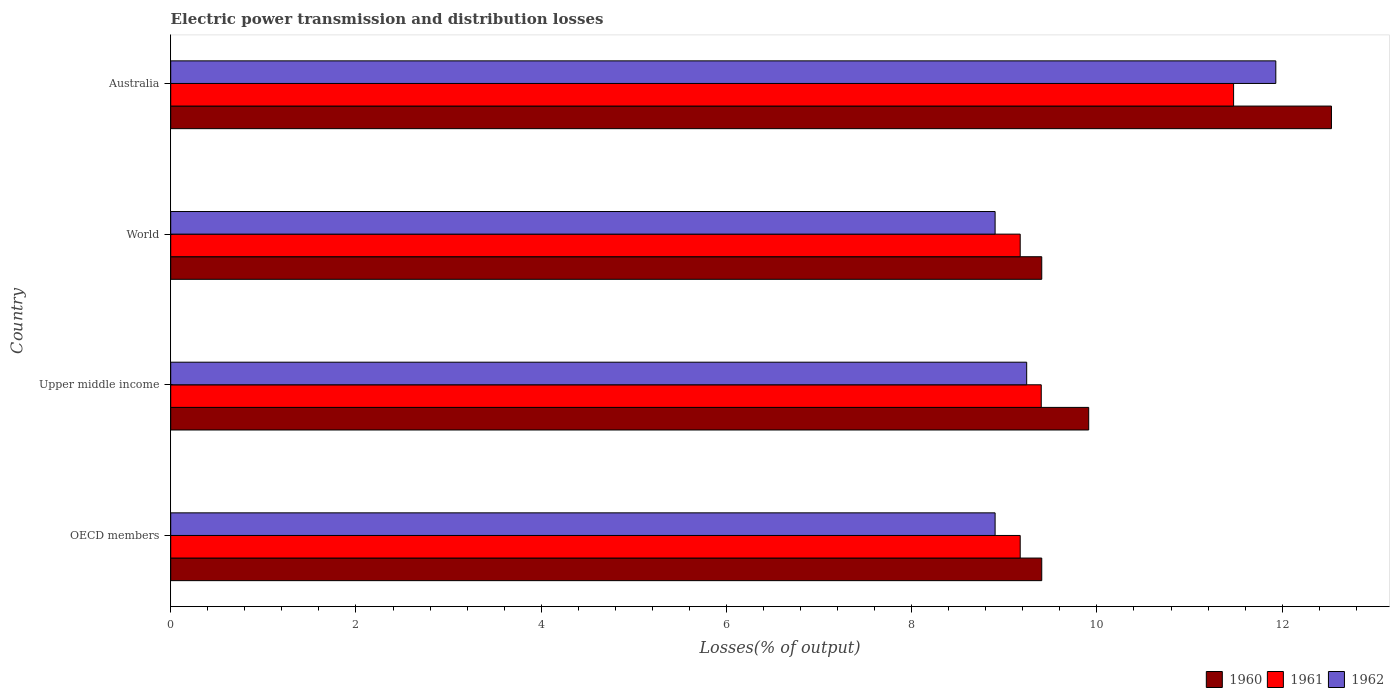How many different coloured bars are there?
Provide a succinct answer. 3. Are the number of bars per tick equal to the number of legend labels?
Offer a very short reply. Yes. Are the number of bars on each tick of the Y-axis equal?
Ensure brevity in your answer.  Yes. How many bars are there on the 4th tick from the top?
Your answer should be compact. 3. What is the label of the 3rd group of bars from the top?
Your answer should be compact. Upper middle income. In how many cases, is the number of bars for a given country not equal to the number of legend labels?
Keep it short and to the point. 0. What is the electric power transmission and distribution losses in 1960 in OECD members?
Make the answer very short. 9.4. Across all countries, what is the maximum electric power transmission and distribution losses in 1962?
Make the answer very short. 11.93. Across all countries, what is the minimum electric power transmission and distribution losses in 1961?
Your answer should be compact. 9.17. In which country was the electric power transmission and distribution losses in 1960 maximum?
Provide a succinct answer. Australia. What is the total electric power transmission and distribution losses in 1962 in the graph?
Make the answer very short. 38.97. What is the difference between the electric power transmission and distribution losses in 1962 in OECD members and that in Upper middle income?
Offer a very short reply. -0.34. What is the difference between the electric power transmission and distribution losses in 1960 in Upper middle income and the electric power transmission and distribution losses in 1962 in OECD members?
Make the answer very short. 1.01. What is the average electric power transmission and distribution losses in 1962 per country?
Make the answer very short. 9.74. What is the difference between the electric power transmission and distribution losses in 1961 and electric power transmission and distribution losses in 1960 in Australia?
Your response must be concise. -1.06. In how many countries, is the electric power transmission and distribution losses in 1961 greater than 9.6 %?
Make the answer very short. 1. What is the ratio of the electric power transmission and distribution losses in 1961 in Australia to that in Upper middle income?
Provide a short and direct response. 1.22. Is the electric power transmission and distribution losses in 1961 in Australia less than that in World?
Give a very brief answer. No. Is the difference between the electric power transmission and distribution losses in 1961 in Upper middle income and World greater than the difference between the electric power transmission and distribution losses in 1960 in Upper middle income and World?
Your answer should be very brief. No. What is the difference between the highest and the second highest electric power transmission and distribution losses in 1961?
Offer a terse response. 2.08. What is the difference between the highest and the lowest electric power transmission and distribution losses in 1962?
Your answer should be compact. 3.03. In how many countries, is the electric power transmission and distribution losses in 1962 greater than the average electric power transmission and distribution losses in 1962 taken over all countries?
Offer a terse response. 1. What does the 3rd bar from the top in World represents?
Provide a succinct answer. 1960. Are all the bars in the graph horizontal?
Provide a short and direct response. Yes. How many countries are there in the graph?
Your response must be concise. 4. What is the difference between two consecutive major ticks on the X-axis?
Your answer should be compact. 2. Are the values on the major ticks of X-axis written in scientific E-notation?
Make the answer very short. No. Does the graph contain grids?
Your answer should be compact. No. What is the title of the graph?
Provide a succinct answer. Electric power transmission and distribution losses. What is the label or title of the X-axis?
Your response must be concise. Losses(% of output). What is the label or title of the Y-axis?
Provide a short and direct response. Country. What is the Losses(% of output) of 1960 in OECD members?
Your response must be concise. 9.4. What is the Losses(% of output) of 1961 in OECD members?
Keep it short and to the point. 9.17. What is the Losses(% of output) in 1962 in OECD members?
Your response must be concise. 8.9. What is the Losses(% of output) in 1960 in Upper middle income?
Your answer should be compact. 9.91. What is the Losses(% of output) of 1961 in Upper middle income?
Your answer should be very brief. 9.4. What is the Losses(% of output) of 1962 in Upper middle income?
Your answer should be compact. 9.24. What is the Losses(% of output) in 1960 in World?
Your answer should be very brief. 9.4. What is the Losses(% of output) of 1961 in World?
Offer a very short reply. 9.17. What is the Losses(% of output) of 1962 in World?
Give a very brief answer. 8.9. What is the Losses(% of output) in 1960 in Australia?
Keep it short and to the point. 12.53. What is the Losses(% of output) of 1961 in Australia?
Your answer should be compact. 11.48. What is the Losses(% of output) of 1962 in Australia?
Your answer should be very brief. 11.93. Across all countries, what is the maximum Losses(% of output) in 1960?
Offer a very short reply. 12.53. Across all countries, what is the maximum Losses(% of output) of 1961?
Ensure brevity in your answer.  11.48. Across all countries, what is the maximum Losses(% of output) of 1962?
Provide a succinct answer. 11.93. Across all countries, what is the minimum Losses(% of output) in 1960?
Your response must be concise. 9.4. Across all countries, what is the minimum Losses(% of output) in 1961?
Keep it short and to the point. 9.17. Across all countries, what is the minimum Losses(% of output) in 1962?
Your answer should be compact. 8.9. What is the total Losses(% of output) in 1960 in the graph?
Your answer should be very brief. 41.25. What is the total Losses(% of output) of 1961 in the graph?
Provide a short and direct response. 39.22. What is the total Losses(% of output) in 1962 in the graph?
Offer a terse response. 38.97. What is the difference between the Losses(% of output) of 1960 in OECD members and that in Upper middle income?
Your answer should be compact. -0.51. What is the difference between the Losses(% of output) in 1961 in OECD members and that in Upper middle income?
Offer a terse response. -0.23. What is the difference between the Losses(% of output) in 1962 in OECD members and that in Upper middle income?
Give a very brief answer. -0.34. What is the difference between the Losses(% of output) of 1962 in OECD members and that in World?
Your response must be concise. 0. What is the difference between the Losses(% of output) in 1960 in OECD members and that in Australia?
Offer a very short reply. -3.13. What is the difference between the Losses(% of output) in 1961 in OECD members and that in Australia?
Your response must be concise. -2.3. What is the difference between the Losses(% of output) of 1962 in OECD members and that in Australia?
Provide a short and direct response. -3.03. What is the difference between the Losses(% of output) in 1960 in Upper middle income and that in World?
Provide a succinct answer. 0.51. What is the difference between the Losses(% of output) in 1961 in Upper middle income and that in World?
Make the answer very short. 0.23. What is the difference between the Losses(% of output) of 1962 in Upper middle income and that in World?
Provide a short and direct response. 0.34. What is the difference between the Losses(% of output) of 1960 in Upper middle income and that in Australia?
Ensure brevity in your answer.  -2.62. What is the difference between the Losses(% of output) of 1961 in Upper middle income and that in Australia?
Keep it short and to the point. -2.08. What is the difference between the Losses(% of output) in 1962 in Upper middle income and that in Australia?
Make the answer very short. -2.69. What is the difference between the Losses(% of output) in 1960 in World and that in Australia?
Give a very brief answer. -3.13. What is the difference between the Losses(% of output) of 1961 in World and that in Australia?
Offer a very short reply. -2.3. What is the difference between the Losses(% of output) of 1962 in World and that in Australia?
Give a very brief answer. -3.03. What is the difference between the Losses(% of output) of 1960 in OECD members and the Losses(% of output) of 1961 in Upper middle income?
Give a very brief answer. 0.01. What is the difference between the Losses(% of output) in 1960 in OECD members and the Losses(% of output) in 1962 in Upper middle income?
Provide a short and direct response. 0.16. What is the difference between the Losses(% of output) in 1961 in OECD members and the Losses(% of output) in 1962 in Upper middle income?
Provide a short and direct response. -0.07. What is the difference between the Losses(% of output) of 1960 in OECD members and the Losses(% of output) of 1961 in World?
Provide a succinct answer. 0.23. What is the difference between the Losses(% of output) in 1960 in OECD members and the Losses(% of output) in 1962 in World?
Keep it short and to the point. 0.5. What is the difference between the Losses(% of output) in 1961 in OECD members and the Losses(% of output) in 1962 in World?
Offer a very short reply. 0.27. What is the difference between the Losses(% of output) in 1960 in OECD members and the Losses(% of output) in 1961 in Australia?
Your answer should be compact. -2.07. What is the difference between the Losses(% of output) in 1960 in OECD members and the Losses(% of output) in 1962 in Australia?
Keep it short and to the point. -2.53. What is the difference between the Losses(% of output) in 1961 in OECD members and the Losses(% of output) in 1962 in Australia?
Provide a succinct answer. -2.76. What is the difference between the Losses(% of output) in 1960 in Upper middle income and the Losses(% of output) in 1961 in World?
Ensure brevity in your answer.  0.74. What is the difference between the Losses(% of output) of 1960 in Upper middle income and the Losses(% of output) of 1962 in World?
Offer a terse response. 1.01. What is the difference between the Losses(% of output) in 1961 in Upper middle income and the Losses(% of output) in 1962 in World?
Provide a succinct answer. 0.5. What is the difference between the Losses(% of output) in 1960 in Upper middle income and the Losses(% of output) in 1961 in Australia?
Offer a very short reply. -1.56. What is the difference between the Losses(% of output) of 1960 in Upper middle income and the Losses(% of output) of 1962 in Australia?
Keep it short and to the point. -2.02. What is the difference between the Losses(% of output) in 1961 in Upper middle income and the Losses(% of output) in 1962 in Australia?
Your response must be concise. -2.53. What is the difference between the Losses(% of output) of 1960 in World and the Losses(% of output) of 1961 in Australia?
Offer a very short reply. -2.07. What is the difference between the Losses(% of output) in 1960 in World and the Losses(% of output) in 1962 in Australia?
Ensure brevity in your answer.  -2.53. What is the difference between the Losses(% of output) in 1961 in World and the Losses(% of output) in 1962 in Australia?
Your answer should be compact. -2.76. What is the average Losses(% of output) in 1960 per country?
Provide a succinct answer. 10.31. What is the average Losses(% of output) in 1961 per country?
Keep it short and to the point. 9.8. What is the average Losses(% of output) in 1962 per country?
Provide a succinct answer. 9.74. What is the difference between the Losses(% of output) in 1960 and Losses(% of output) in 1961 in OECD members?
Offer a very short reply. 0.23. What is the difference between the Losses(% of output) in 1960 and Losses(% of output) in 1962 in OECD members?
Provide a succinct answer. 0.5. What is the difference between the Losses(% of output) in 1961 and Losses(% of output) in 1962 in OECD members?
Ensure brevity in your answer.  0.27. What is the difference between the Losses(% of output) of 1960 and Losses(% of output) of 1961 in Upper middle income?
Offer a very short reply. 0.51. What is the difference between the Losses(% of output) of 1960 and Losses(% of output) of 1962 in Upper middle income?
Provide a short and direct response. 0.67. What is the difference between the Losses(% of output) in 1961 and Losses(% of output) in 1962 in Upper middle income?
Provide a succinct answer. 0.16. What is the difference between the Losses(% of output) of 1960 and Losses(% of output) of 1961 in World?
Provide a succinct answer. 0.23. What is the difference between the Losses(% of output) in 1960 and Losses(% of output) in 1962 in World?
Provide a succinct answer. 0.5. What is the difference between the Losses(% of output) of 1961 and Losses(% of output) of 1962 in World?
Provide a short and direct response. 0.27. What is the difference between the Losses(% of output) of 1960 and Losses(% of output) of 1961 in Australia?
Keep it short and to the point. 1.06. What is the difference between the Losses(% of output) of 1960 and Losses(% of output) of 1962 in Australia?
Your response must be concise. 0.6. What is the difference between the Losses(% of output) of 1961 and Losses(% of output) of 1962 in Australia?
Provide a short and direct response. -0.46. What is the ratio of the Losses(% of output) in 1960 in OECD members to that in Upper middle income?
Offer a terse response. 0.95. What is the ratio of the Losses(% of output) of 1961 in OECD members to that in Upper middle income?
Make the answer very short. 0.98. What is the ratio of the Losses(% of output) in 1962 in OECD members to that in Upper middle income?
Your answer should be very brief. 0.96. What is the ratio of the Losses(% of output) in 1960 in OECD members to that in Australia?
Offer a terse response. 0.75. What is the ratio of the Losses(% of output) in 1961 in OECD members to that in Australia?
Ensure brevity in your answer.  0.8. What is the ratio of the Losses(% of output) of 1962 in OECD members to that in Australia?
Give a very brief answer. 0.75. What is the ratio of the Losses(% of output) of 1960 in Upper middle income to that in World?
Give a very brief answer. 1.05. What is the ratio of the Losses(% of output) in 1961 in Upper middle income to that in World?
Your answer should be very brief. 1.02. What is the ratio of the Losses(% of output) of 1962 in Upper middle income to that in World?
Your answer should be compact. 1.04. What is the ratio of the Losses(% of output) of 1960 in Upper middle income to that in Australia?
Provide a succinct answer. 0.79. What is the ratio of the Losses(% of output) of 1961 in Upper middle income to that in Australia?
Make the answer very short. 0.82. What is the ratio of the Losses(% of output) in 1962 in Upper middle income to that in Australia?
Give a very brief answer. 0.77. What is the ratio of the Losses(% of output) of 1960 in World to that in Australia?
Your answer should be very brief. 0.75. What is the ratio of the Losses(% of output) in 1961 in World to that in Australia?
Keep it short and to the point. 0.8. What is the ratio of the Losses(% of output) in 1962 in World to that in Australia?
Your answer should be very brief. 0.75. What is the difference between the highest and the second highest Losses(% of output) in 1960?
Provide a succinct answer. 2.62. What is the difference between the highest and the second highest Losses(% of output) of 1961?
Your answer should be very brief. 2.08. What is the difference between the highest and the second highest Losses(% of output) of 1962?
Make the answer very short. 2.69. What is the difference between the highest and the lowest Losses(% of output) in 1960?
Offer a terse response. 3.13. What is the difference between the highest and the lowest Losses(% of output) in 1961?
Your answer should be compact. 2.3. What is the difference between the highest and the lowest Losses(% of output) of 1962?
Keep it short and to the point. 3.03. 